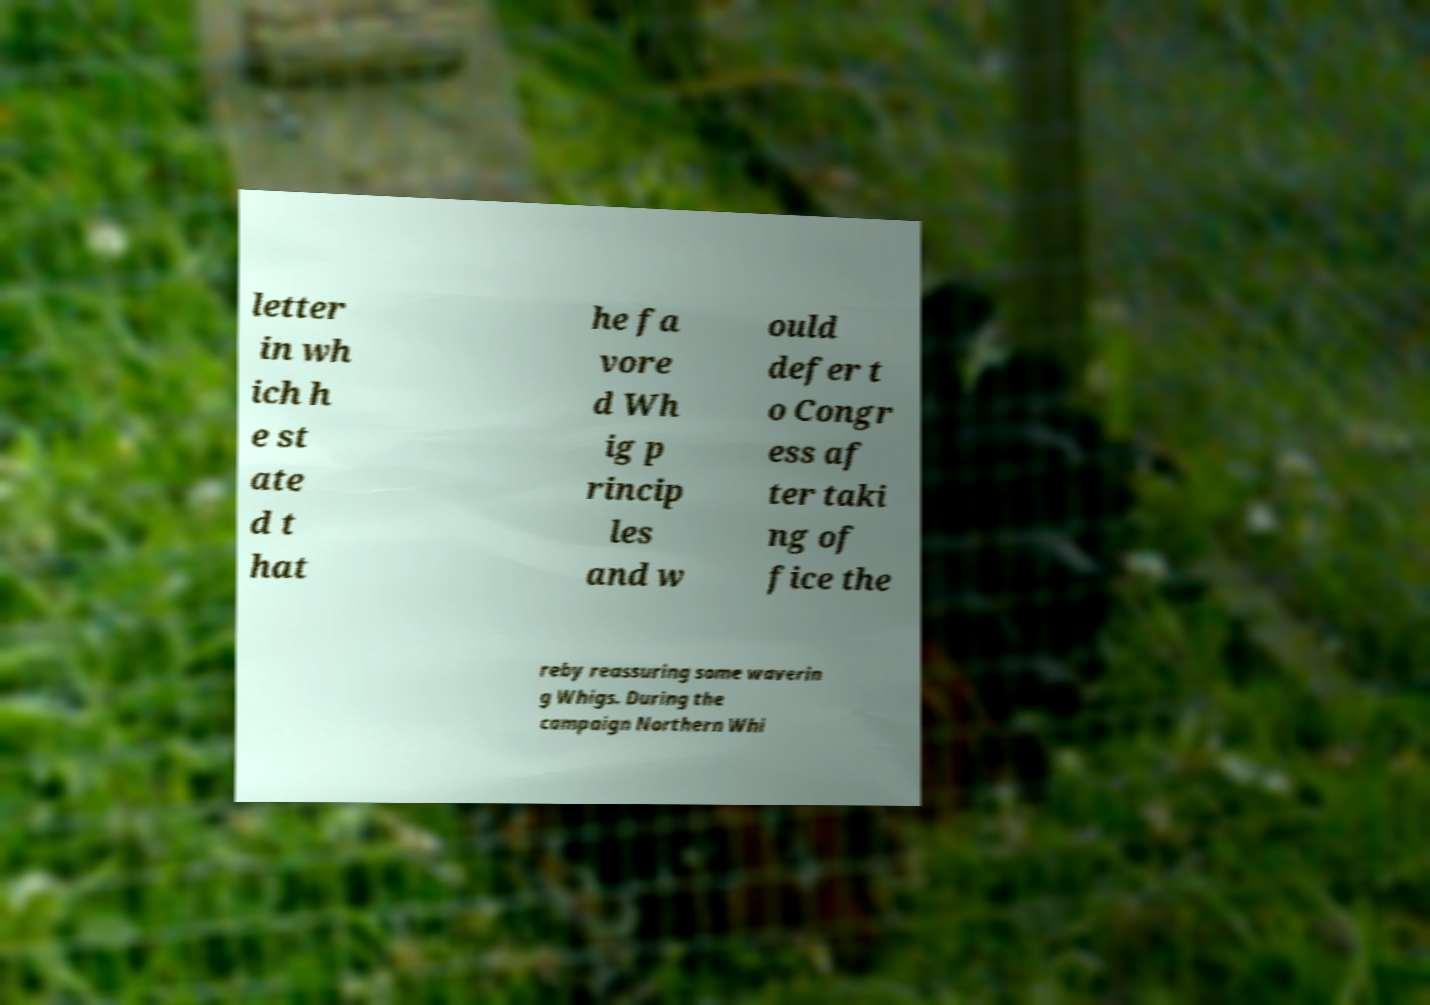Please read and relay the text visible in this image. What does it say? letter in wh ich h e st ate d t hat he fa vore d Wh ig p rincip les and w ould defer t o Congr ess af ter taki ng of fice the reby reassuring some waverin g Whigs. During the campaign Northern Whi 